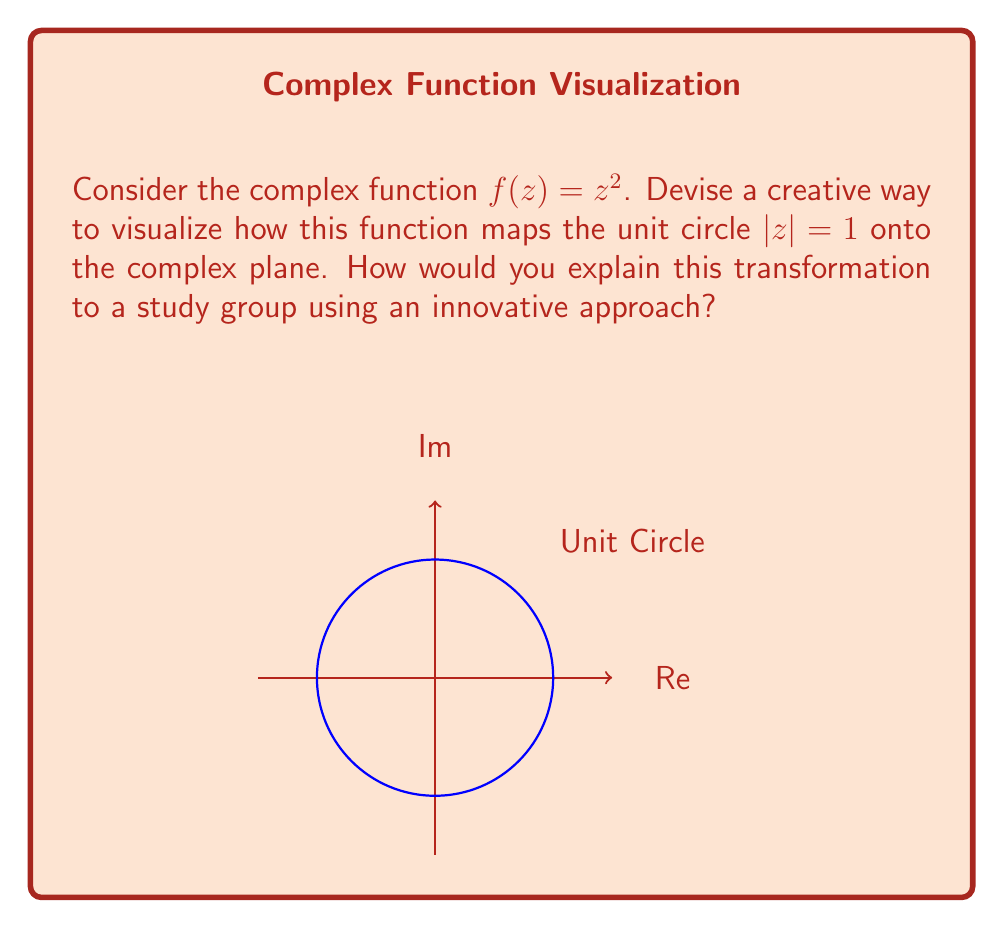Show me your answer to this math problem. To visualize this complex function mapping, we can follow these creative steps:

1) First, let's parameterize the unit circle:
   $$z = e^{i\theta} = \cos\theta + i\sin\theta, \quad 0 \leq \theta < 2\pi$$

2) Now, apply the function $f(z) = z^2$:
   $$f(z) = (e^{i\theta})^2 = e^{2i\theta} = \cos(2\theta) + i\sin(2\theta)$$

3) Innovative visualization technique:
   - Imagine the unit circle as a rubber band.
   - As $\theta$ increases from 0 to $2\pi$, the point $z$ travels once around the circle.
   - However, $f(z)$ travels twice around its image.

4) To demonstrate this to a study group:
   - Draw a unit circle on a stretchable material (like a balloon).
   - Mark points at regular intervals (e.g., every 45°).
   - Now, stretch the circle so that each point moves twice as far along the circumference.
   - The result is a larger circle that has been "doubled back" on itself.

5) Key observations:
   - The unit circle $|z| = 1$ maps to a circle $|w| = 1^2 = 1$.
   - Each point on the original circle corresponds to two points on the image circle.
   - The mapping is 2-to-1, except at $z = \pm 1$, where it's 1-to-1.

6) This visualization demonstrates important properties of the mapping:
   - Conformal: it preserves angles locally.
   - Doubles angles: a 45° angle in the z-plane becomes a 90° angle in the w-plane.
   - Squares distances: points twice as far from the origin on the z-plane map to points four times as far on the w-plane.
Answer: The function $f(z) = z^2$ maps the unit circle onto itself, wrapping it twice around and doubling angles. 